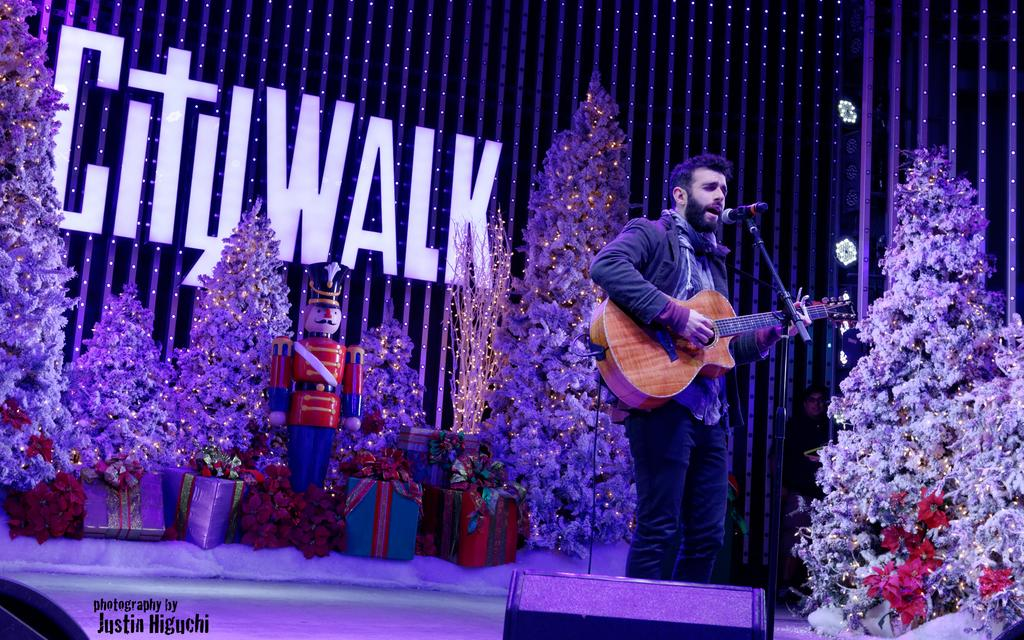What is the man in the image doing? The man is playing the guitar in the image. How is the man playing the guitar? The man is using his hand to play the guitar. What is in front of the man? There is a microphone in front of the man. What can be seen in the background of the image? There is a Christmas tree, flowers, gift boxes, and toys in the background. What is the cause of the band's success in the image? There is no band present in the image, so it is not possible to determine the cause of their success. 